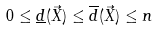<formula> <loc_0><loc_0><loc_500><loc_500>0 \leq \underline { d } ( \vec { X } ) \leq \overline { d } ( \vec { X } ) \leq n</formula> 